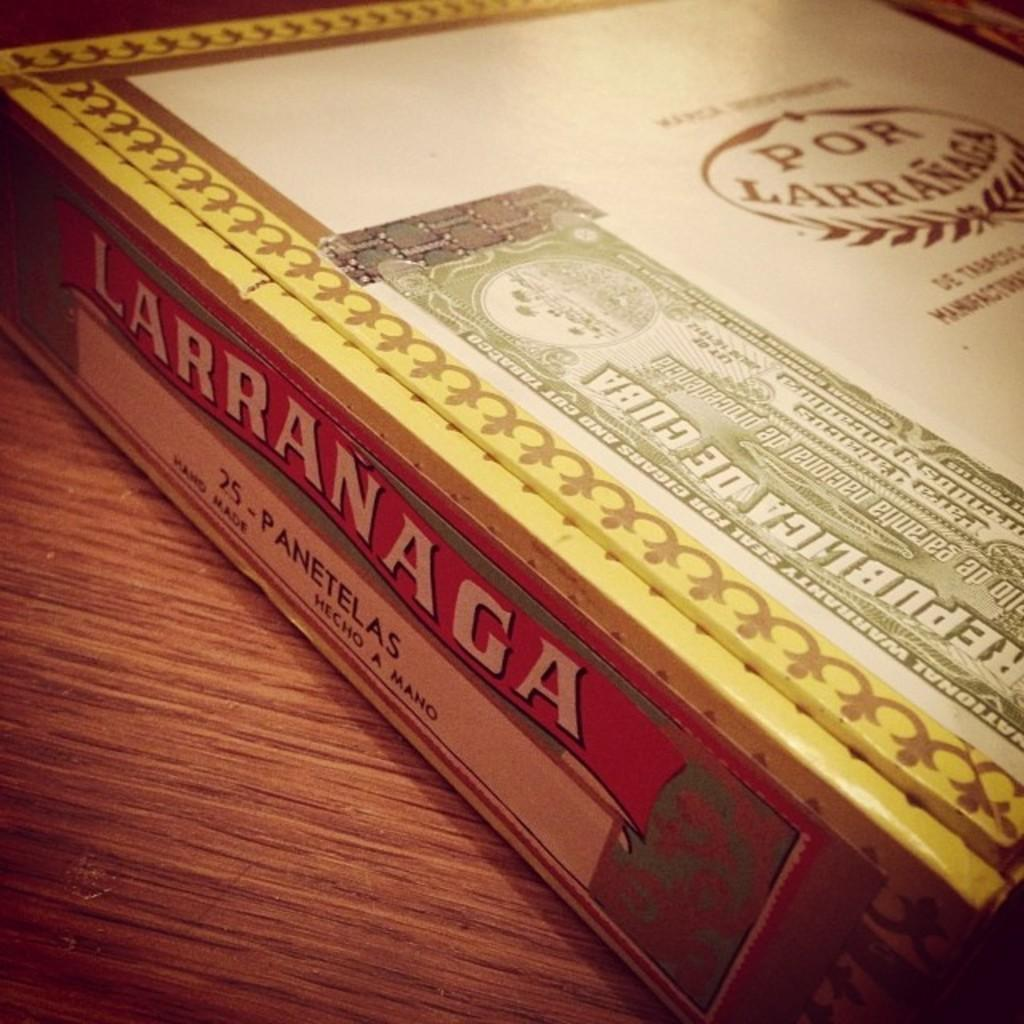<image>
Relay a brief, clear account of the picture shown. the word larranaga is on the side of a white book 